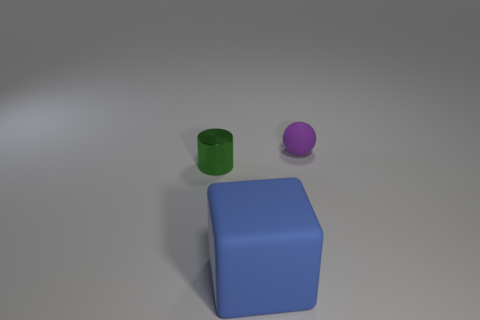Is there anything else that has the same material as the small green cylinder?
Keep it short and to the point. No. How big is the rubber thing that is behind the cube?
Keep it short and to the point. Small. There is a object to the right of the rubber block; are there any small rubber objects to the left of it?
Provide a succinct answer. No. Is the thing that is to the right of the blue cube made of the same material as the tiny green cylinder?
Give a very brief answer. No. How many matte things are in front of the small purple object and behind the green cylinder?
Make the answer very short. 0. What number of spheres are made of the same material as the cube?
Your answer should be very brief. 1. There is another object that is the same material as the purple object; what is its color?
Offer a terse response. Blue. Is the number of purple objects less than the number of small things?
Provide a succinct answer. Yes. What is the material of the object that is to the right of the object in front of the tiny thing that is in front of the sphere?
Your answer should be compact. Rubber. What material is the tiny purple sphere?
Your answer should be compact. Rubber. 